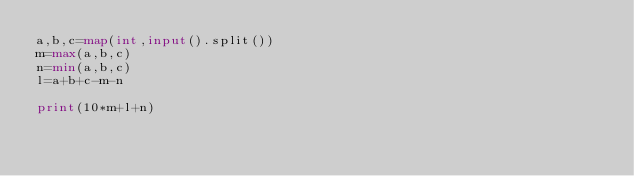Convert code to text. <code><loc_0><loc_0><loc_500><loc_500><_Python_>a,b,c=map(int,input().split())
m=max(a,b,c)
n=min(a,b,c)
l=a+b+c-m-n

print(10*m+l+n)</code> 